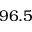Convert formula to latex. <formula><loc_0><loc_0><loc_500><loc_500>9 6 . 5</formula> 